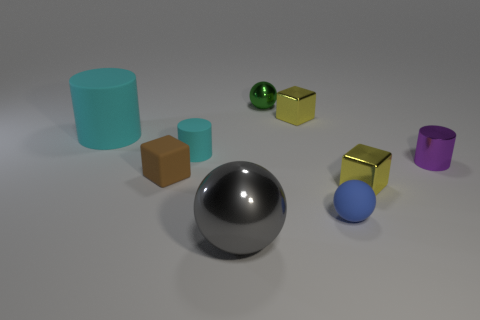What number of objects are either small yellow cubes or rubber things in front of the big matte cylinder?
Provide a succinct answer. 5. What number of things are either small spheres behind the small purple metallic object or tiny shiny things in front of the green metal object?
Your answer should be compact. 4. Are there any blue matte things in front of the tiny purple metal cylinder?
Make the answer very short. Yes. The metallic thing that is on the left side of the metallic ball on the right side of the shiny ball in front of the small brown block is what color?
Provide a succinct answer. Gray. Does the small purple shiny object have the same shape as the big cyan thing?
Give a very brief answer. Yes. What color is the cylinder that is made of the same material as the big sphere?
Give a very brief answer. Purple. What number of things are either yellow things that are in front of the brown rubber thing or small green shiny objects?
Your answer should be very brief. 2. What size is the cyan rubber thing in front of the big cyan rubber thing?
Offer a terse response. Small. There is a brown matte cube; is its size the same as the object that is in front of the small rubber ball?
Provide a short and direct response. No. There is a shiny ball behind the matte thing that is left of the tiny brown cube; what color is it?
Your answer should be compact. Green. 